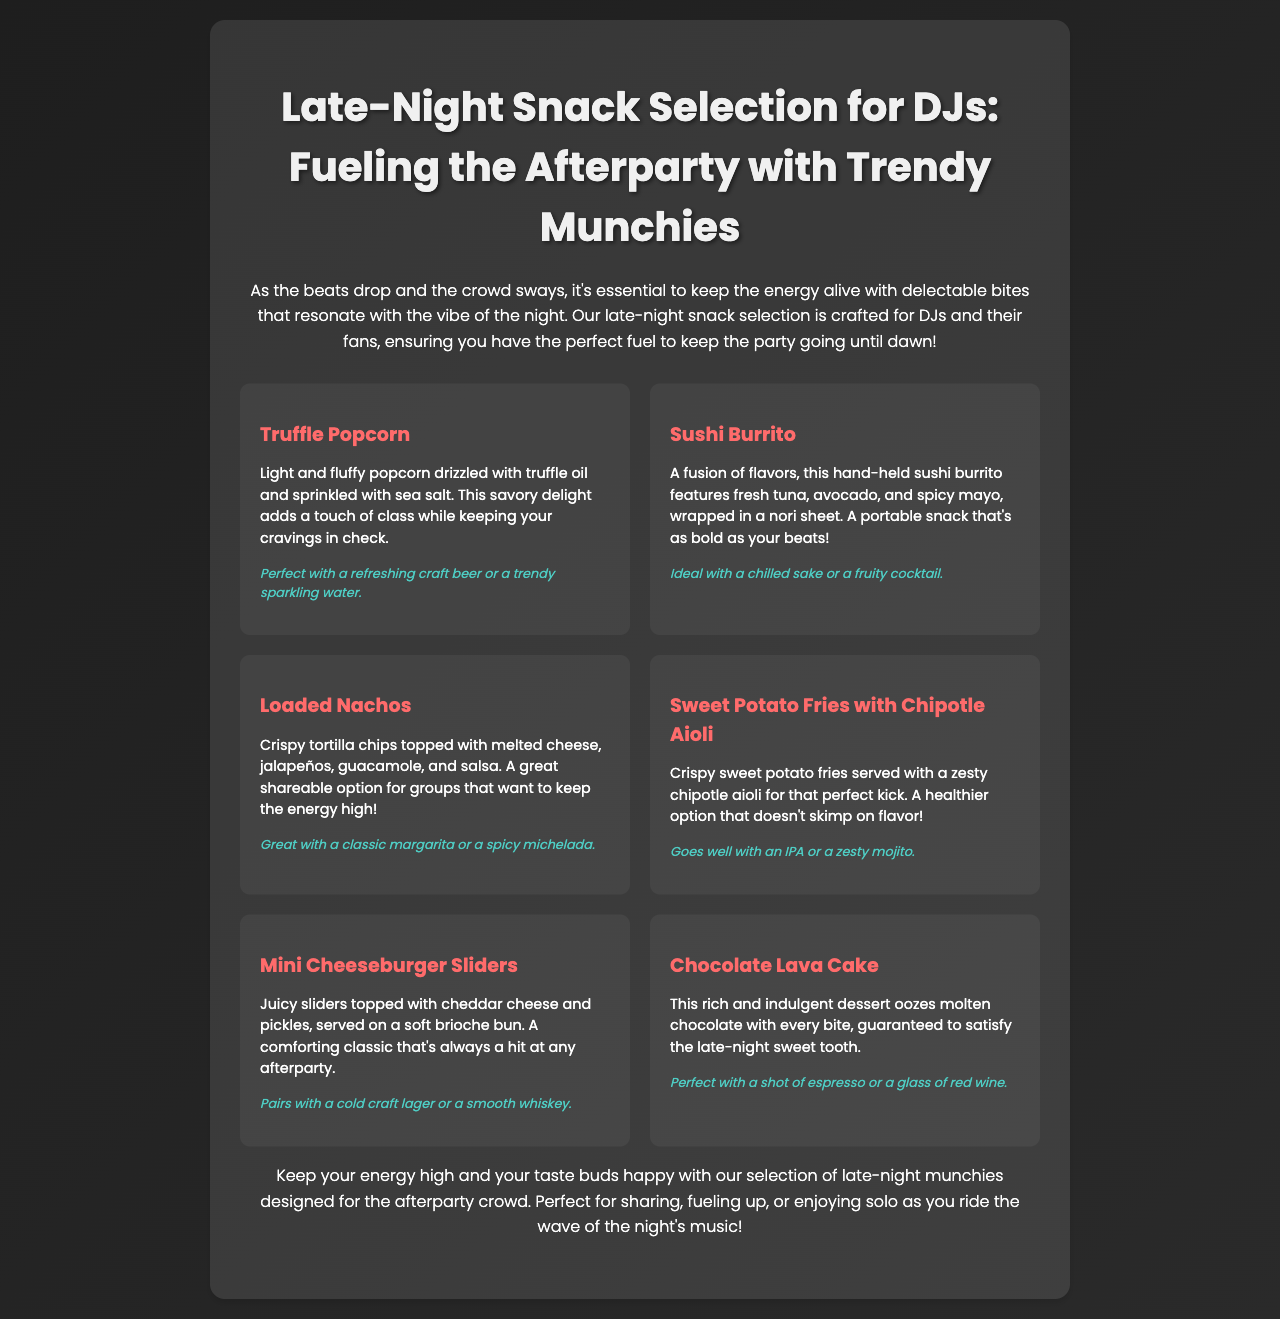What is the title of the menu? The title of the menu is presented prominently at the top of the document.
Answer: Late-Night Snack Selection for DJs: Fueling the Afterparty with Trendy Munchies How many snack items are listed in the document? The document lists a total of six snack items in the selection.
Answer: 6 Which snack contains truffle oil? This snack is highlighted as having a luxurious touch that complements its flavor profile.
Answer: Truffle Popcorn What type of drink pairs well with the Sushi Burrito? The document explicitly states an ideal drink pairing for this item.
Answer: Chilled sake or a fruity cocktail What is the main ingredient in the Loaded Nachos? The description highlights a key component featured in this snack.
Answer: Cheese Which snack is described as a healthier option? The sweet potato fries are noted for their healthier attributes compared to traditional fries.
Answer: Sweet Potato Fries with Chipotle Aioli What is the description of the Chocolate Lava Cake? The description outlines its characteristics and appeal as a late-night dessert choice.
Answer: Rich and indulgent dessert oozes molten chocolate What is mentioned as the ideal drink pairing for the Mini Cheeseburger Sliders? This beverage complements the flavors of the sliders as mentioned in the menu.
Answer: Cold craft lager or a smooth whiskey 